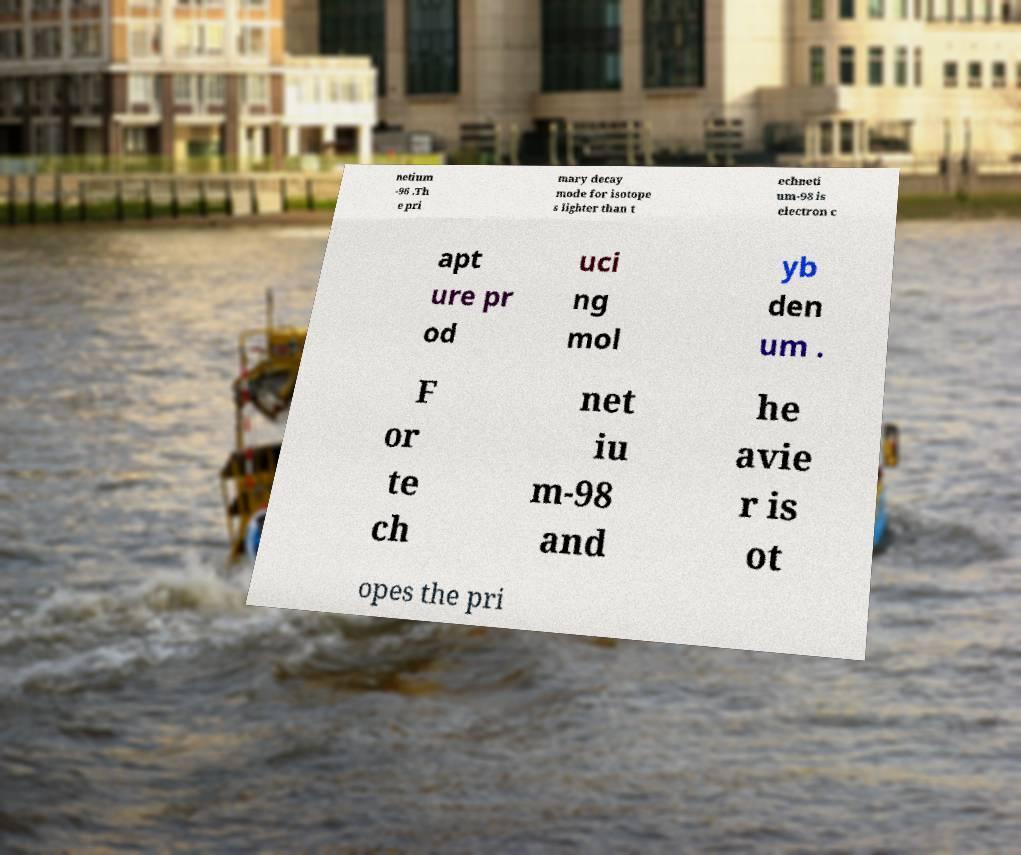Can you accurately transcribe the text from the provided image for me? netium -96 .Th e pri mary decay mode for isotope s lighter than t echneti um-98 is electron c apt ure pr od uci ng mol yb den um . F or te ch net iu m-98 and he avie r is ot opes the pri 